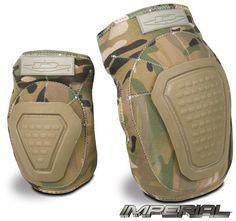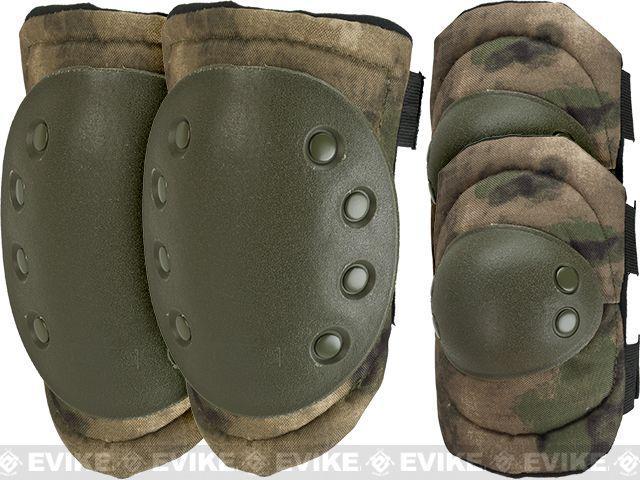The first image is the image on the left, the second image is the image on the right. For the images displayed, is the sentence "There are camp patterned knee pads" factually correct? Answer yes or no. Yes. The first image is the image on the left, the second image is the image on the right. Evaluate the accuracy of this statement regarding the images: "At least one image shows a pair of kneepads with a camo pattern.". Is it true? Answer yes or no. Yes. 